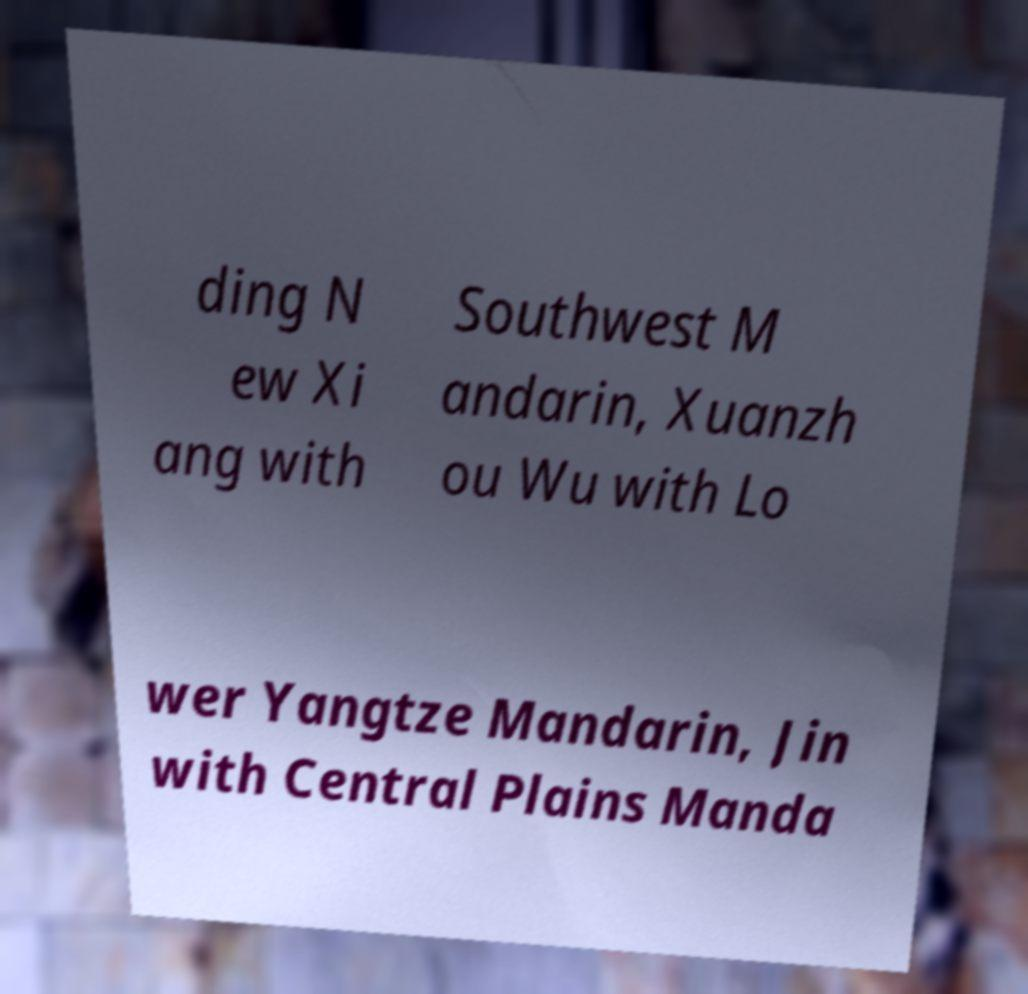There's text embedded in this image that I need extracted. Can you transcribe it verbatim? ding N ew Xi ang with Southwest M andarin, Xuanzh ou Wu with Lo wer Yangtze Mandarin, Jin with Central Plains Manda 